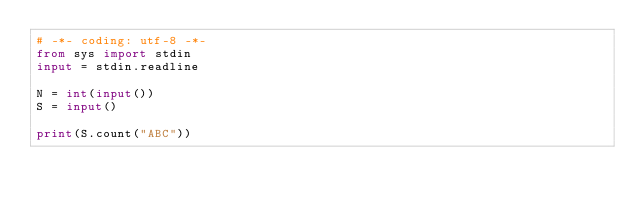Convert code to text. <code><loc_0><loc_0><loc_500><loc_500><_Python_># -*- coding: utf-8 -*-
from sys import stdin
input = stdin.readline

N = int(input())
S = input()

print(S.count("ABC"))</code> 